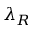Convert formula to latex. <formula><loc_0><loc_0><loc_500><loc_500>\lambda _ { R }</formula> 